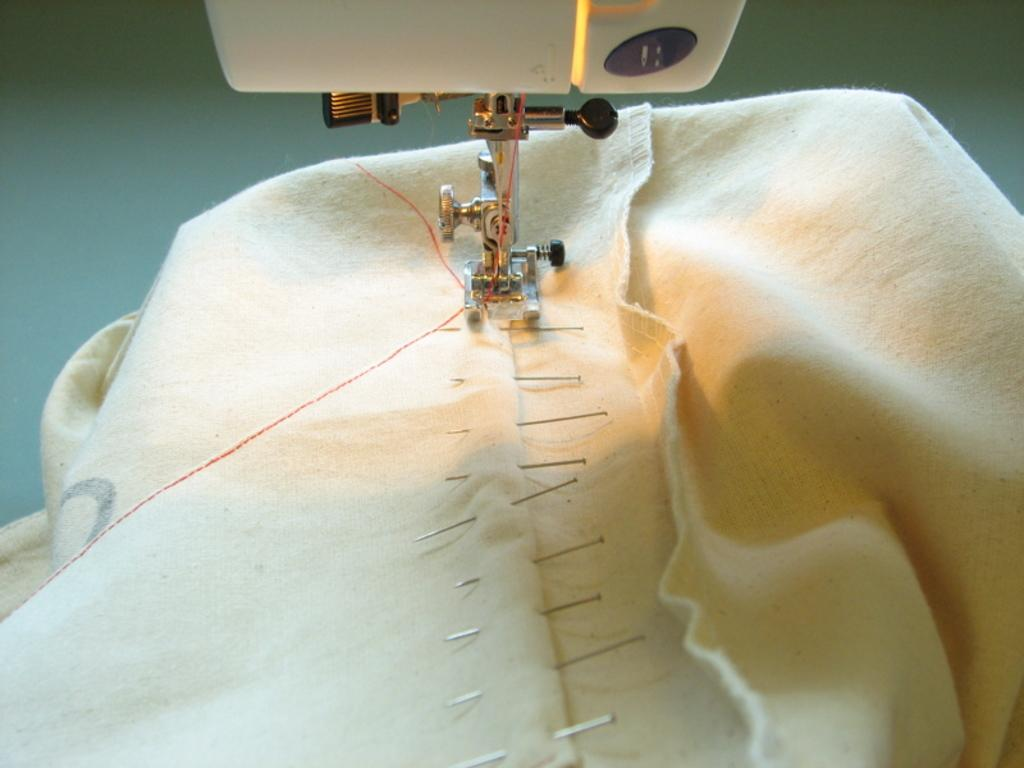What is the main object in the image? There is a cloth in the image. What can be seen on the cloth? There are needles on the cloth. What tool is present in the image? There is a stitching machine present in the image. What type of ring can be seen on the stitching machine in the image? There is no ring present on the stitching machine in the image. Is there a baseball being stitched on the cloth in the image? There is no baseball visible in the image; only needles are present on the cloth. 